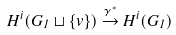Convert formula to latex. <formula><loc_0><loc_0><loc_500><loc_500>H ^ { i } ( G _ { 1 } \sqcup \{ v \} ) \overset { \gamma ^ { * } } { \rightarrow } H ^ { i } ( G _ { 1 } )</formula> 